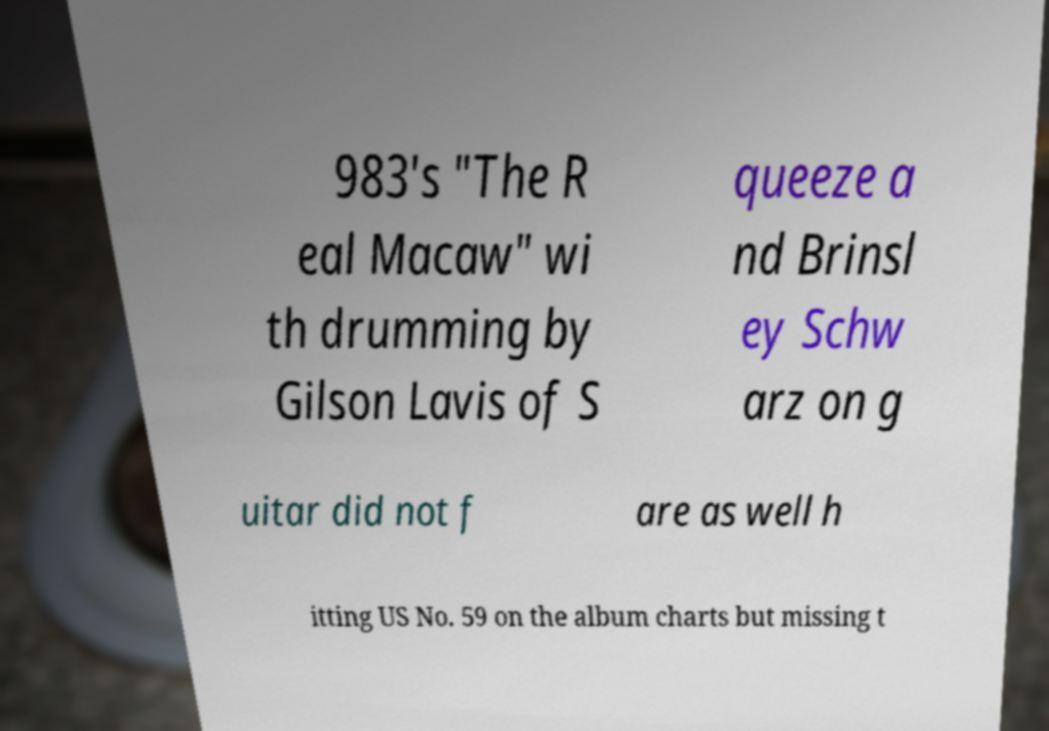I need the written content from this picture converted into text. Can you do that? 983's "The R eal Macaw" wi th drumming by Gilson Lavis of S queeze a nd Brinsl ey Schw arz on g uitar did not f are as well h itting US No. 59 on the album charts but missing t 